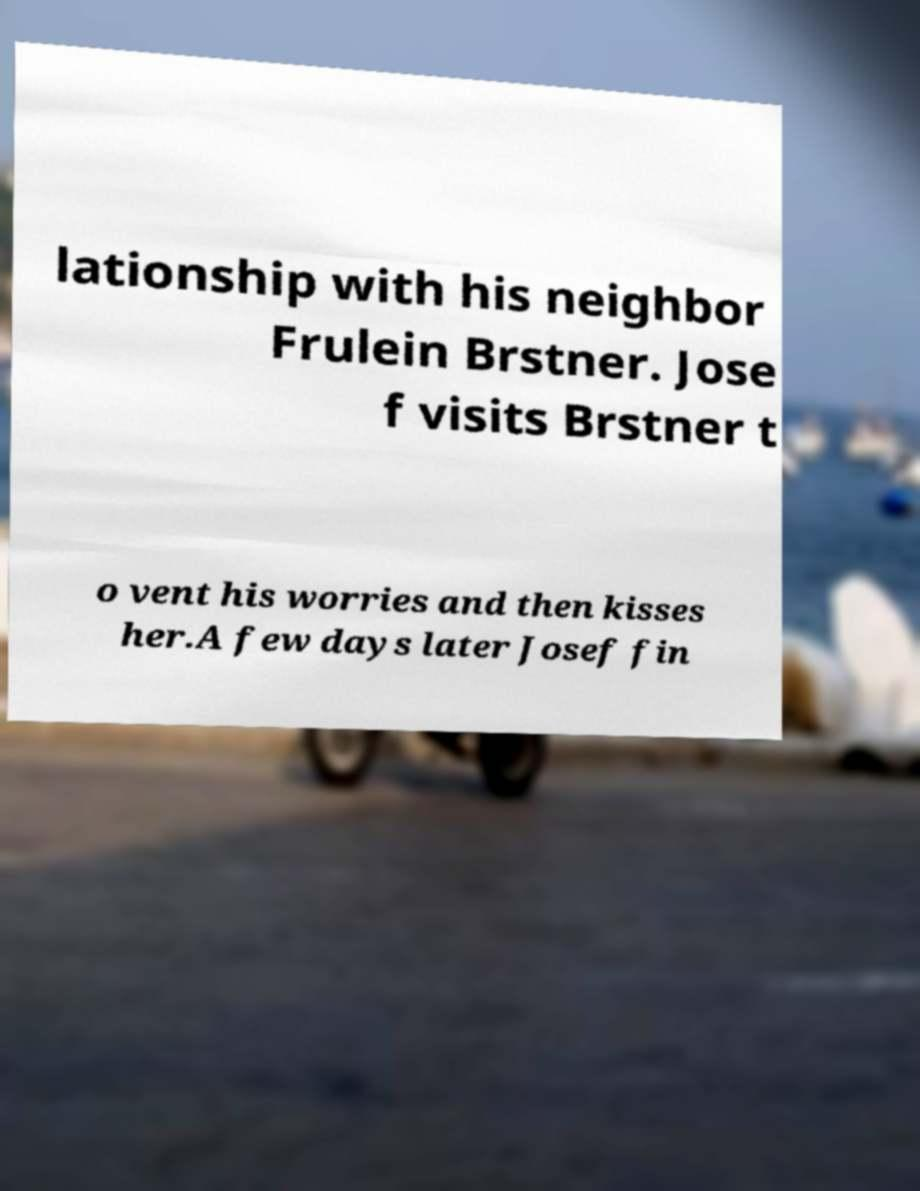There's text embedded in this image that I need extracted. Can you transcribe it verbatim? lationship with his neighbor Frulein Brstner. Jose f visits Brstner t o vent his worries and then kisses her.A few days later Josef fin 